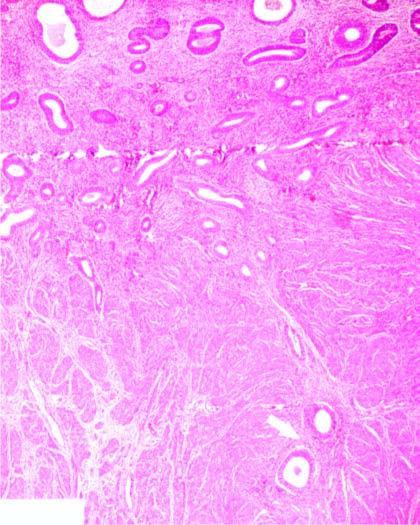what are the endometrial glands present deep inside?
Answer the question using a single word or phrase. Myometrium 